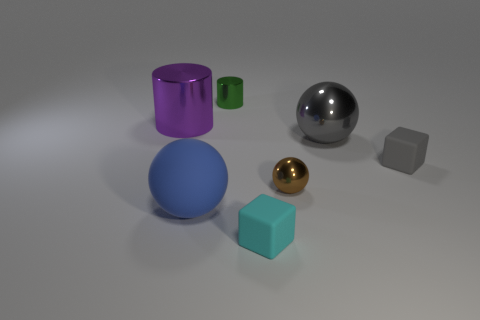Subtract all big balls. How many balls are left? 1 Subtract 2 spheres. How many spheres are left? 1 Subtract all brown balls. How many balls are left? 2 Add 2 big matte spheres. How many objects exist? 9 Subtract all blocks. How many objects are left? 5 Add 4 rubber blocks. How many rubber blocks are left? 6 Add 2 brown metallic cubes. How many brown metallic cubes exist? 2 Subtract 0 red balls. How many objects are left? 7 Subtract all cyan cubes. Subtract all blue balls. How many cubes are left? 1 Subtract all yellow cylinders. How many blue cubes are left? 0 